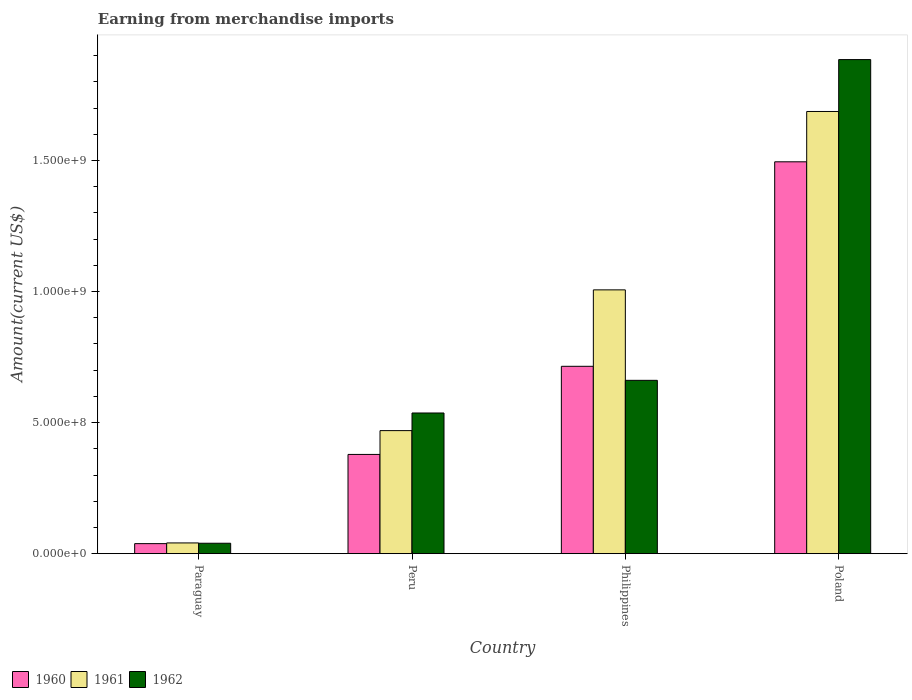Are the number of bars per tick equal to the number of legend labels?
Your response must be concise. Yes. How many bars are there on the 4th tick from the right?
Ensure brevity in your answer.  3. What is the label of the 1st group of bars from the left?
Make the answer very short. Paraguay. What is the amount earned from merchandise imports in 1960 in Philippines?
Keep it short and to the point. 7.15e+08. Across all countries, what is the maximum amount earned from merchandise imports in 1961?
Provide a succinct answer. 1.69e+09. Across all countries, what is the minimum amount earned from merchandise imports in 1961?
Your answer should be compact. 4.09e+07. In which country was the amount earned from merchandise imports in 1962 maximum?
Make the answer very short. Poland. In which country was the amount earned from merchandise imports in 1960 minimum?
Offer a very short reply. Paraguay. What is the total amount earned from merchandise imports in 1962 in the graph?
Your answer should be very brief. 3.12e+09. What is the difference between the amount earned from merchandise imports in 1962 in Paraguay and that in Peru?
Provide a short and direct response. -4.97e+08. What is the difference between the amount earned from merchandise imports in 1960 in Philippines and the amount earned from merchandise imports in 1961 in Poland?
Ensure brevity in your answer.  -9.72e+08. What is the average amount earned from merchandise imports in 1961 per country?
Make the answer very short. 8.01e+08. What is the difference between the amount earned from merchandise imports of/in 1960 and amount earned from merchandise imports of/in 1961 in Paraguay?
Provide a succinct answer. -2.70e+06. What is the ratio of the amount earned from merchandise imports in 1962 in Paraguay to that in Peru?
Offer a terse response. 0.07. Is the difference between the amount earned from merchandise imports in 1960 in Peru and Philippines greater than the difference between the amount earned from merchandise imports in 1961 in Peru and Philippines?
Your answer should be very brief. Yes. What is the difference between the highest and the second highest amount earned from merchandise imports in 1961?
Your answer should be very brief. 6.81e+08. What is the difference between the highest and the lowest amount earned from merchandise imports in 1960?
Keep it short and to the point. 1.46e+09. In how many countries, is the amount earned from merchandise imports in 1961 greater than the average amount earned from merchandise imports in 1961 taken over all countries?
Ensure brevity in your answer.  2. Is the sum of the amount earned from merchandise imports in 1960 in Peru and Philippines greater than the maximum amount earned from merchandise imports in 1961 across all countries?
Your response must be concise. No. What does the 1st bar from the left in Paraguay represents?
Offer a very short reply. 1960. How many countries are there in the graph?
Provide a short and direct response. 4. What is the difference between two consecutive major ticks on the Y-axis?
Provide a succinct answer. 5.00e+08. Does the graph contain grids?
Provide a short and direct response. No. Where does the legend appear in the graph?
Offer a very short reply. Bottom left. How many legend labels are there?
Make the answer very short. 3. How are the legend labels stacked?
Your response must be concise. Horizontal. What is the title of the graph?
Offer a very short reply. Earning from merchandise imports. Does "1962" appear as one of the legend labels in the graph?
Your answer should be compact. Yes. What is the label or title of the Y-axis?
Ensure brevity in your answer.  Amount(current US$). What is the Amount(current US$) of 1960 in Paraguay?
Your response must be concise. 3.82e+07. What is the Amount(current US$) of 1961 in Paraguay?
Ensure brevity in your answer.  4.09e+07. What is the Amount(current US$) of 1962 in Paraguay?
Your answer should be very brief. 3.97e+07. What is the Amount(current US$) of 1960 in Peru?
Your answer should be very brief. 3.79e+08. What is the Amount(current US$) of 1961 in Peru?
Offer a terse response. 4.69e+08. What is the Amount(current US$) in 1962 in Peru?
Your answer should be very brief. 5.37e+08. What is the Amount(current US$) of 1960 in Philippines?
Your response must be concise. 7.15e+08. What is the Amount(current US$) in 1961 in Philippines?
Your answer should be compact. 1.01e+09. What is the Amount(current US$) in 1962 in Philippines?
Keep it short and to the point. 6.61e+08. What is the Amount(current US$) in 1960 in Poland?
Provide a succinct answer. 1.50e+09. What is the Amount(current US$) in 1961 in Poland?
Give a very brief answer. 1.69e+09. What is the Amount(current US$) of 1962 in Poland?
Provide a succinct answer. 1.88e+09. Across all countries, what is the maximum Amount(current US$) in 1960?
Offer a terse response. 1.50e+09. Across all countries, what is the maximum Amount(current US$) of 1961?
Your response must be concise. 1.69e+09. Across all countries, what is the maximum Amount(current US$) of 1962?
Your response must be concise. 1.88e+09. Across all countries, what is the minimum Amount(current US$) of 1960?
Your answer should be very brief. 3.82e+07. Across all countries, what is the minimum Amount(current US$) of 1961?
Keep it short and to the point. 4.09e+07. Across all countries, what is the minimum Amount(current US$) in 1962?
Your response must be concise. 3.97e+07. What is the total Amount(current US$) of 1960 in the graph?
Your response must be concise. 2.63e+09. What is the total Amount(current US$) in 1961 in the graph?
Provide a short and direct response. 3.20e+09. What is the total Amount(current US$) of 1962 in the graph?
Make the answer very short. 3.12e+09. What is the difference between the Amount(current US$) of 1960 in Paraguay and that in Peru?
Your answer should be compact. -3.40e+08. What is the difference between the Amount(current US$) in 1961 in Paraguay and that in Peru?
Offer a terse response. -4.28e+08. What is the difference between the Amount(current US$) of 1962 in Paraguay and that in Peru?
Your response must be concise. -4.97e+08. What is the difference between the Amount(current US$) of 1960 in Paraguay and that in Philippines?
Make the answer very short. -6.77e+08. What is the difference between the Amount(current US$) of 1961 in Paraguay and that in Philippines?
Provide a short and direct response. -9.66e+08. What is the difference between the Amount(current US$) of 1962 in Paraguay and that in Philippines?
Your answer should be compact. -6.22e+08. What is the difference between the Amount(current US$) of 1960 in Paraguay and that in Poland?
Offer a terse response. -1.46e+09. What is the difference between the Amount(current US$) of 1961 in Paraguay and that in Poland?
Give a very brief answer. -1.65e+09. What is the difference between the Amount(current US$) of 1962 in Paraguay and that in Poland?
Ensure brevity in your answer.  -1.85e+09. What is the difference between the Amount(current US$) of 1960 in Peru and that in Philippines?
Your answer should be compact. -3.36e+08. What is the difference between the Amount(current US$) in 1961 in Peru and that in Philippines?
Ensure brevity in your answer.  -5.37e+08. What is the difference between the Amount(current US$) in 1962 in Peru and that in Philippines?
Provide a succinct answer. -1.25e+08. What is the difference between the Amount(current US$) in 1960 in Peru and that in Poland?
Ensure brevity in your answer.  -1.12e+09. What is the difference between the Amount(current US$) of 1961 in Peru and that in Poland?
Your response must be concise. -1.22e+09. What is the difference between the Amount(current US$) of 1962 in Peru and that in Poland?
Provide a short and direct response. -1.35e+09. What is the difference between the Amount(current US$) in 1960 in Philippines and that in Poland?
Provide a short and direct response. -7.80e+08. What is the difference between the Amount(current US$) of 1961 in Philippines and that in Poland?
Keep it short and to the point. -6.81e+08. What is the difference between the Amount(current US$) of 1962 in Philippines and that in Poland?
Offer a terse response. -1.22e+09. What is the difference between the Amount(current US$) of 1960 in Paraguay and the Amount(current US$) of 1961 in Peru?
Offer a terse response. -4.31e+08. What is the difference between the Amount(current US$) in 1960 in Paraguay and the Amount(current US$) in 1962 in Peru?
Offer a terse response. -4.98e+08. What is the difference between the Amount(current US$) in 1961 in Paraguay and the Amount(current US$) in 1962 in Peru?
Your response must be concise. -4.96e+08. What is the difference between the Amount(current US$) in 1960 in Paraguay and the Amount(current US$) in 1961 in Philippines?
Give a very brief answer. -9.68e+08. What is the difference between the Amount(current US$) of 1960 in Paraguay and the Amount(current US$) of 1962 in Philippines?
Your answer should be very brief. -6.23e+08. What is the difference between the Amount(current US$) of 1961 in Paraguay and the Amount(current US$) of 1962 in Philippines?
Offer a very short reply. -6.20e+08. What is the difference between the Amount(current US$) of 1960 in Paraguay and the Amount(current US$) of 1961 in Poland?
Make the answer very short. -1.65e+09. What is the difference between the Amount(current US$) in 1960 in Paraguay and the Amount(current US$) in 1962 in Poland?
Offer a terse response. -1.85e+09. What is the difference between the Amount(current US$) in 1961 in Paraguay and the Amount(current US$) in 1962 in Poland?
Offer a very short reply. -1.84e+09. What is the difference between the Amount(current US$) of 1960 in Peru and the Amount(current US$) of 1961 in Philippines?
Offer a terse response. -6.28e+08. What is the difference between the Amount(current US$) in 1960 in Peru and the Amount(current US$) in 1962 in Philippines?
Your answer should be very brief. -2.83e+08. What is the difference between the Amount(current US$) of 1961 in Peru and the Amount(current US$) of 1962 in Philippines?
Provide a succinct answer. -1.92e+08. What is the difference between the Amount(current US$) in 1960 in Peru and the Amount(current US$) in 1961 in Poland?
Offer a very short reply. -1.31e+09. What is the difference between the Amount(current US$) in 1960 in Peru and the Amount(current US$) in 1962 in Poland?
Your answer should be compact. -1.51e+09. What is the difference between the Amount(current US$) in 1961 in Peru and the Amount(current US$) in 1962 in Poland?
Your answer should be very brief. -1.42e+09. What is the difference between the Amount(current US$) of 1960 in Philippines and the Amount(current US$) of 1961 in Poland?
Offer a very short reply. -9.72e+08. What is the difference between the Amount(current US$) of 1960 in Philippines and the Amount(current US$) of 1962 in Poland?
Your answer should be compact. -1.17e+09. What is the difference between the Amount(current US$) of 1961 in Philippines and the Amount(current US$) of 1962 in Poland?
Offer a terse response. -8.79e+08. What is the average Amount(current US$) in 1960 per country?
Make the answer very short. 6.57e+08. What is the average Amount(current US$) of 1961 per country?
Give a very brief answer. 8.01e+08. What is the average Amount(current US$) in 1962 per country?
Ensure brevity in your answer.  7.81e+08. What is the difference between the Amount(current US$) in 1960 and Amount(current US$) in 1961 in Paraguay?
Make the answer very short. -2.70e+06. What is the difference between the Amount(current US$) of 1960 and Amount(current US$) of 1962 in Paraguay?
Your answer should be very brief. -1.50e+06. What is the difference between the Amount(current US$) of 1961 and Amount(current US$) of 1962 in Paraguay?
Make the answer very short. 1.20e+06. What is the difference between the Amount(current US$) in 1960 and Amount(current US$) in 1961 in Peru?
Provide a succinct answer. -9.08e+07. What is the difference between the Amount(current US$) of 1960 and Amount(current US$) of 1962 in Peru?
Keep it short and to the point. -1.58e+08. What is the difference between the Amount(current US$) of 1961 and Amount(current US$) of 1962 in Peru?
Offer a very short reply. -6.73e+07. What is the difference between the Amount(current US$) in 1960 and Amount(current US$) in 1961 in Philippines?
Ensure brevity in your answer.  -2.92e+08. What is the difference between the Amount(current US$) of 1960 and Amount(current US$) of 1962 in Philippines?
Your response must be concise. 5.35e+07. What is the difference between the Amount(current US$) of 1961 and Amount(current US$) of 1962 in Philippines?
Your answer should be compact. 3.45e+08. What is the difference between the Amount(current US$) of 1960 and Amount(current US$) of 1961 in Poland?
Your answer should be very brief. -1.92e+08. What is the difference between the Amount(current US$) of 1960 and Amount(current US$) of 1962 in Poland?
Offer a terse response. -3.90e+08. What is the difference between the Amount(current US$) of 1961 and Amount(current US$) of 1962 in Poland?
Offer a very short reply. -1.98e+08. What is the ratio of the Amount(current US$) of 1960 in Paraguay to that in Peru?
Ensure brevity in your answer.  0.1. What is the ratio of the Amount(current US$) of 1961 in Paraguay to that in Peru?
Your answer should be compact. 0.09. What is the ratio of the Amount(current US$) of 1962 in Paraguay to that in Peru?
Your answer should be very brief. 0.07. What is the ratio of the Amount(current US$) of 1960 in Paraguay to that in Philippines?
Provide a succinct answer. 0.05. What is the ratio of the Amount(current US$) in 1961 in Paraguay to that in Philippines?
Give a very brief answer. 0.04. What is the ratio of the Amount(current US$) in 1962 in Paraguay to that in Philippines?
Ensure brevity in your answer.  0.06. What is the ratio of the Amount(current US$) of 1960 in Paraguay to that in Poland?
Provide a short and direct response. 0.03. What is the ratio of the Amount(current US$) in 1961 in Paraguay to that in Poland?
Offer a terse response. 0.02. What is the ratio of the Amount(current US$) in 1962 in Paraguay to that in Poland?
Ensure brevity in your answer.  0.02. What is the ratio of the Amount(current US$) in 1960 in Peru to that in Philippines?
Keep it short and to the point. 0.53. What is the ratio of the Amount(current US$) of 1961 in Peru to that in Philippines?
Provide a short and direct response. 0.47. What is the ratio of the Amount(current US$) of 1962 in Peru to that in Philippines?
Your response must be concise. 0.81. What is the ratio of the Amount(current US$) of 1960 in Peru to that in Poland?
Your answer should be compact. 0.25. What is the ratio of the Amount(current US$) in 1961 in Peru to that in Poland?
Provide a short and direct response. 0.28. What is the ratio of the Amount(current US$) in 1962 in Peru to that in Poland?
Keep it short and to the point. 0.28. What is the ratio of the Amount(current US$) in 1960 in Philippines to that in Poland?
Your answer should be very brief. 0.48. What is the ratio of the Amount(current US$) in 1961 in Philippines to that in Poland?
Offer a terse response. 0.6. What is the ratio of the Amount(current US$) in 1962 in Philippines to that in Poland?
Provide a succinct answer. 0.35. What is the difference between the highest and the second highest Amount(current US$) of 1960?
Your answer should be very brief. 7.80e+08. What is the difference between the highest and the second highest Amount(current US$) of 1961?
Ensure brevity in your answer.  6.81e+08. What is the difference between the highest and the second highest Amount(current US$) of 1962?
Make the answer very short. 1.22e+09. What is the difference between the highest and the lowest Amount(current US$) of 1960?
Keep it short and to the point. 1.46e+09. What is the difference between the highest and the lowest Amount(current US$) of 1961?
Ensure brevity in your answer.  1.65e+09. What is the difference between the highest and the lowest Amount(current US$) of 1962?
Keep it short and to the point. 1.85e+09. 